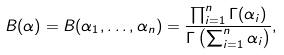Convert formula to latex. <formula><loc_0><loc_0><loc_500><loc_500>B ( \alpha ) = B ( \alpha _ { 1 } , \dots , \alpha _ { n } ) = \frac { \prod _ { i = 1 } ^ { n } \Gamma ( \alpha _ { i } ) } { \Gamma \left ( \sum _ { i = 1 } ^ { n } \alpha _ { i } \right ) } ,</formula> 